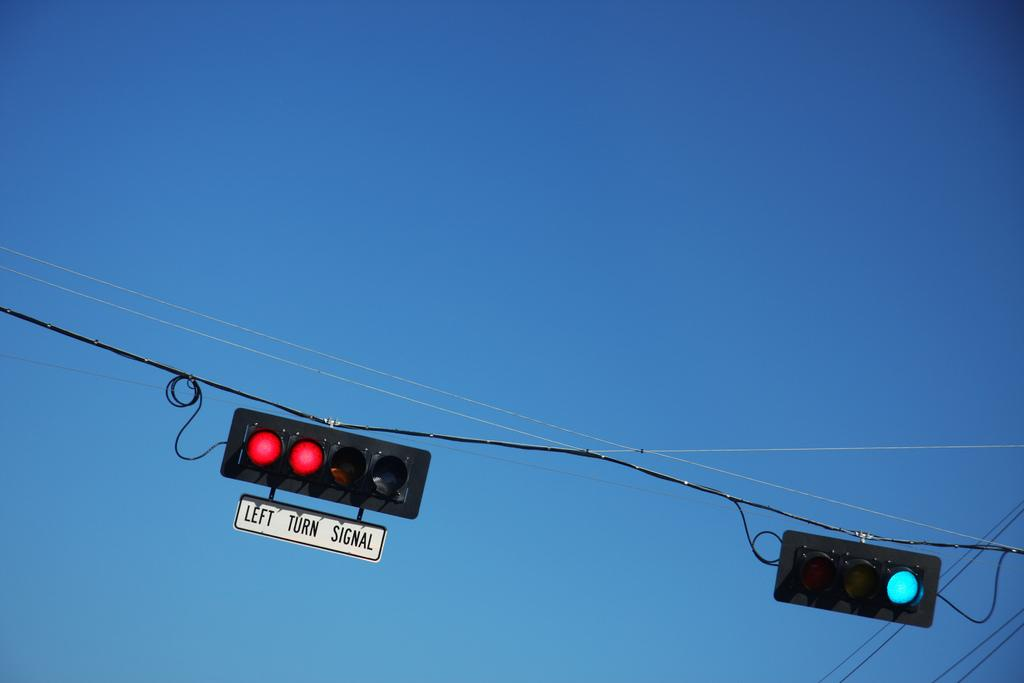What type of object is present in the image that regulates traffic? There are traffic lights in the image. How are the traffic lights suspended in the image? The traffic lights are attached to a cable. What can be observed about the weather in the image? The sky is clear in the image. Can you see a trail leading to a lake in the image? There is no trail or lake present in the image. Is there a dog visible in the image? There is no dog present in the image. 